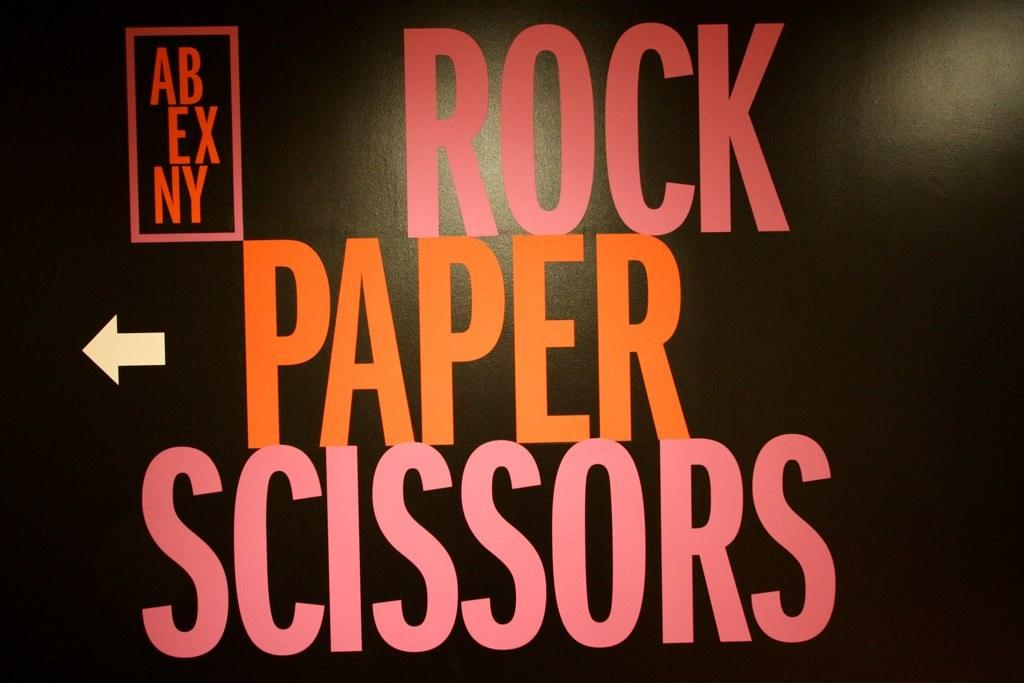<image>
Describe the image concisely. a black wall that says 'rock paper scissors' on it 